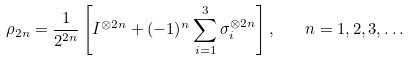Convert formula to latex. <formula><loc_0><loc_0><loc_500><loc_500>\rho _ { 2 n } = \frac { 1 } { 2 ^ { 2 n } } \left [ I ^ { \otimes 2 n } + ( - 1 ) ^ { n } \sum _ { i = 1 } ^ { 3 } \sigma _ { i } ^ { \otimes 2 n } \right ] , \quad n = 1 , 2 , 3 , \dots</formula> 